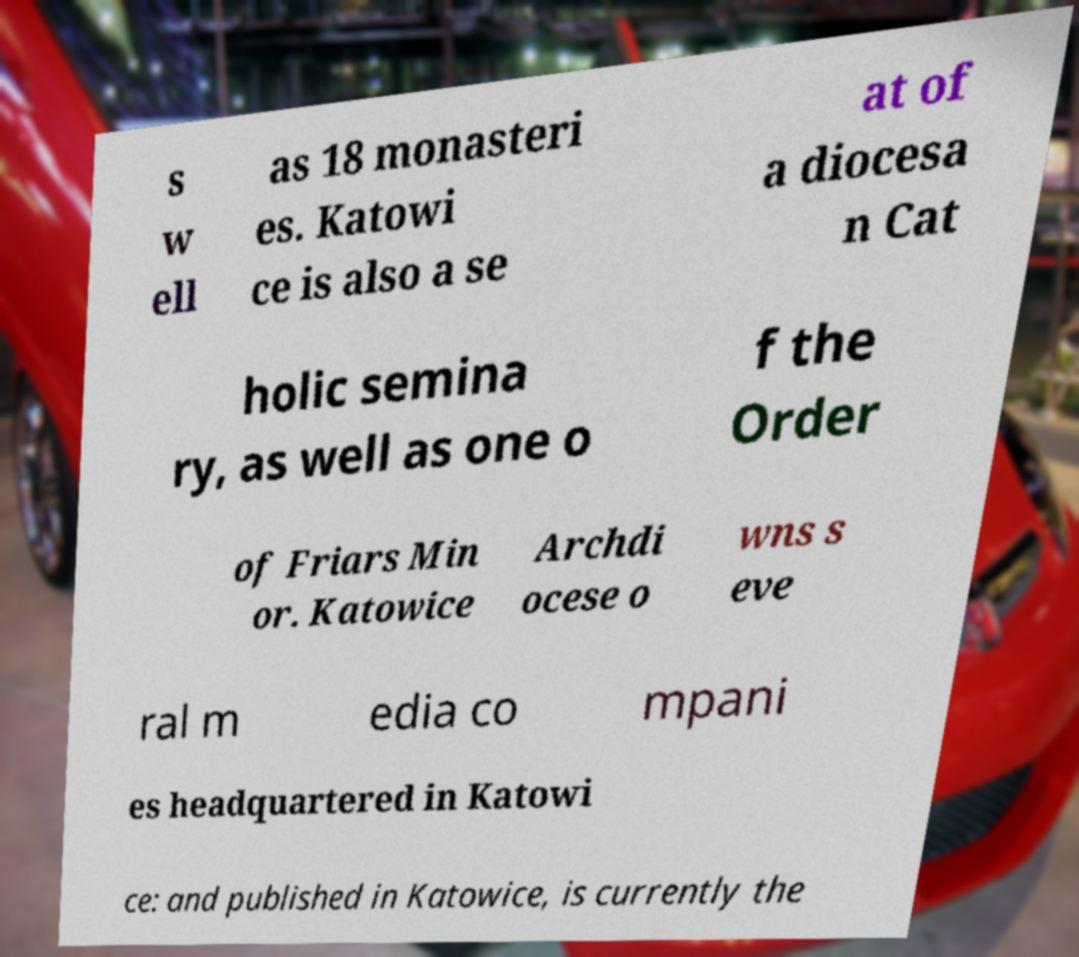For documentation purposes, I need the text within this image transcribed. Could you provide that? s w ell as 18 monasteri es. Katowi ce is also a se at of a diocesa n Cat holic semina ry, as well as one o f the Order of Friars Min or. Katowice Archdi ocese o wns s eve ral m edia co mpani es headquartered in Katowi ce: and published in Katowice, is currently the 